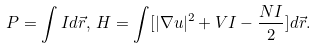<formula> <loc_0><loc_0><loc_500><loc_500>P = \int I d \vec { r } , \, H = \int [ | \nabla u | ^ { 2 } + V I - \frac { N I } { 2 } ] d \vec { r } .</formula> 